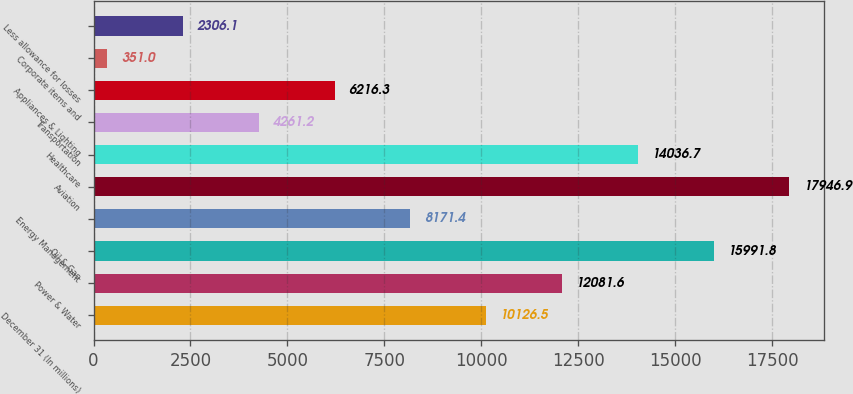Convert chart. <chart><loc_0><loc_0><loc_500><loc_500><bar_chart><fcel>December 31 (In millions)<fcel>Power & Water<fcel>Oil & Gas<fcel>Energy Management<fcel>Aviation<fcel>Healthcare<fcel>Transportation<fcel>Appliances & Lighting<fcel>Corporate items and<fcel>Less allowance for losses<nl><fcel>10126.5<fcel>12081.6<fcel>15991.8<fcel>8171.4<fcel>17946.9<fcel>14036.7<fcel>4261.2<fcel>6216.3<fcel>351<fcel>2306.1<nl></chart> 